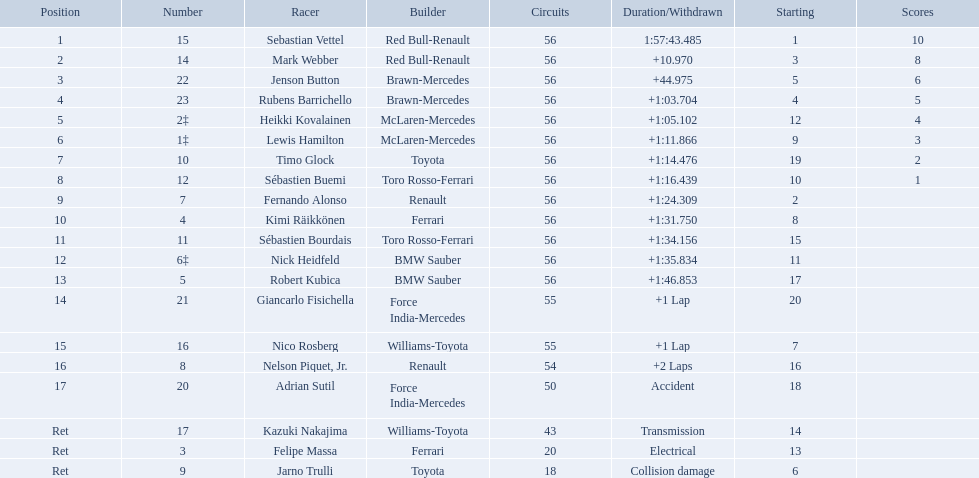Which drivers raced in the 2009 chinese grand prix? Sebastian Vettel, Mark Webber, Jenson Button, Rubens Barrichello, Heikki Kovalainen, Lewis Hamilton, Timo Glock, Sébastien Buemi, Fernando Alonso, Kimi Räikkönen, Sébastien Bourdais, Nick Heidfeld, Robert Kubica, Giancarlo Fisichella, Nico Rosberg, Nelson Piquet, Jr., Adrian Sutil, Kazuki Nakajima, Felipe Massa, Jarno Trulli. Help me parse the entirety of this table. {'header': ['Position', 'Number', 'Racer', 'Builder', 'Circuits', 'Duration/Withdrawn', 'Starting', 'Scores'], 'rows': [['1', '15', 'Sebastian Vettel', 'Red Bull-Renault', '56', '1:57:43.485', '1', '10'], ['2', '14', 'Mark Webber', 'Red Bull-Renault', '56', '+10.970', '3', '8'], ['3', '22', 'Jenson Button', 'Brawn-Mercedes', '56', '+44.975', '5', '6'], ['4', '23', 'Rubens Barrichello', 'Brawn-Mercedes', '56', '+1:03.704', '4', '5'], ['5', '2‡', 'Heikki Kovalainen', 'McLaren-Mercedes', '56', '+1:05.102', '12', '4'], ['6', '1‡', 'Lewis Hamilton', 'McLaren-Mercedes', '56', '+1:11.866', '9', '3'], ['7', '10', 'Timo Glock', 'Toyota', '56', '+1:14.476', '19', '2'], ['8', '12', 'Sébastien Buemi', 'Toro Rosso-Ferrari', '56', '+1:16.439', '10', '1'], ['9', '7', 'Fernando Alonso', 'Renault', '56', '+1:24.309', '2', ''], ['10', '4', 'Kimi Räikkönen', 'Ferrari', '56', '+1:31.750', '8', ''], ['11', '11', 'Sébastien Bourdais', 'Toro Rosso-Ferrari', '56', '+1:34.156', '15', ''], ['12', '6‡', 'Nick Heidfeld', 'BMW Sauber', '56', '+1:35.834', '11', ''], ['13', '5', 'Robert Kubica', 'BMW Sauber', '56', '+1:46.853', '17', ''], ['14', '21', 'Giancarlo Fisichella', 'Force India-Mercedes', '55', '+1 Lap', '20', ''], ['15', '16', 'Nico Rosberg', 'Williams-Toyota', '55', '+1 Lap', '7', ''], ['16', '8', 'Nelson Piquet, Jr.', 'Renault', '54', '+2 Laps', '16', ''], ['17', '20', 'Adrian Sutil', 'Force India-Mercedes', '50', 'Accident', '18', ''], ['Ret', '17', 'Kazuki Nakajima', 'Williams-Toyota', '43', 'Transmission', '14', ''], ['Ret', '3', 'Felipe Massa', 'Ferrari', '20', 'Electrical', '13', ''], ['Ret', '9', 'Jarno Trulli', 'Toyota', '18', 'Collision damage', '6', '']]} Of the drivers in the 2009 chinese grand prix, which finished the race? Sebastian Vettel, Mark Webber, Jenson Button, Rubens Barrichello, Heikki Kovalainen, Lewis Hamilton, Timo Glock, Sébastien Buemi, Fernando Alonso, Kimi Räikkönen, Sébastien Bourdais, Nick Heidfeld, Robert Kubica. Of the drivers who finished the race, who had the slowest time? Robert Kubica. Can you give me this table in json format? {'header': ['Position', 'Number', 'Racer', 'Builder', 'Circuits', 'Duration/Withdrawn', 'Starting', 'Scores'], 'rows': [['1', '15', 'Sebastian Vettel', 'Red Bull-Renault', '56', '1:57:43.485', '1', '10'], ['2', '14', 'Mark Webber', 'Red Bull-Renault', '56', '+10.970', '3', '8'], ['3', '22', 'Jenson Button', 'Brawn-Mercedes', '56', '+44.975', '5', '6'], ['4', '23', 'Rubens Barrichello', 'Brawn-Mercedes', '56', '+1:03.704', '4', '5'], ['5', '2‡', 'Heikki Kovalainen', 'McLaren-Mercedes', '56', '+1:05.102', '12', '4'], ['6', '1‡', 'Lewis Hamilton', 'McLaren-Mercedes', '56', '+1:11.866', '9', '3'], ['7', '10', 'Timo Glock', 'Toyota', '56', '+1:14.476', '19', '2'], ['8', '12', 'Sébastien Buemi', 'Toro Rosso-Ferrari', '56', '+1:16.439', '10', '1'], ['9', '7', 'Fernando Alonso', 'Renault', '56', '+1:24.309', '2', ''], ['10', '4', 'Kimi Räikkönen', 'Ferrari', '56', '+1:31.750', '8', ''], ['11', '11', 'Sébastien Bourdais', 'Toro Rosso-Ferrari', '56', '+1:34.156', '15', ''], ['12', '6‡', 'Nick Heidfeld', 'BMW Sauber', '56', '+1:35.834', '11', ''], ['13', '5', 'Robert Kubica', 'BMW Sauber', '56', '+1:46.853', '17', ''], ['14', '21', 'Giancarlo Fisichella', 'Force India-Mercedes', '55', '+1 Lap', '20', ''], ['15', '16', 'Nico Rosberg', 'Williams-Toyota', '55', '+1 Lap', '7', ''], ['16', '8', 'Nelson Piquet, Jr.', 'Renault', '54', '+2 Laps', '16', ''], ['17', '20', 'Adrian Sutil', 'Force India-Mercedes', '50', 'Accident', '18', ''], ['Ret', '17', 'Kazuki Nakajima', 'Williams-Toyota', '43', 'Transmission', '14', ''], ['Ret', '3', 'Felipe Massa', 'Ferrari', '20', 'Electrical', '13', ''], ['Ret', '9', 'Jarno Trulli', 'Toyota', '18', 'Collision damage', '6', '']]} Who are all the drivers? Sebastian Vettel, Mark Webber, Jenson Button, Rubens Barrichello, Heikki Kovalainen, Lewis Hamilton, Timo Glock, Sébastien Buemi, Fernando Alonso, Kimi Räikkönen, Sébastien Bourdais, Nick Heidfeld, Robert Kubica, Giancarlo Fisichella, Nico Rosberg, Nelson Piquet, Jr., Adrian Sutil, Kazuki Nakajima, Felipe Massa, Jarno Trulli. What were their finishing times? 1:57:43.485, +10.970, +44.975, +1:03.704, +1:05.102, +1:11.866, +1:14.476, +1:16.439, +1:24.309, +1:31.750, +1:34.156, +1:35.834, +1:46.853, +1 Lap, +1 Lap, +2 Laps, Accident, Transmission, Electrical, Collision damage. Who finished last? Robert Kubica. Who were the drivers at the 2009 chinese grand prix? Sebastian Vettel, Mark Webber, Jenson Button, Rubens Barrichello, Heikki Kovalainen, Lewis Hamilton, Timo Glock, Sébastien Buemi, Fernando Alonso, Kimi Räikkönen, Sébastien Bourdais, Nick Heidfeld, Robert Kubica, Giancarlo Fisichella, Nico Rosberg, Nelson Piquet, Jr., Adrian Sutil, Kazuki Nakajima, Felipe Massa, Jarno Trulli. Who had the slowest time? Robert Kubica. Who were all of the drivers in the 2009 chinese grand prix? Sebastian Vettel, Mark Webber, Jenson Button, Rubens Barrichello, Heikki Kovalainen, Lewis Hamilton, Timo Glock, Sébastien Buemi, Fernando Alonso, Kimi Räikkönen, Sébastien Bourdais, Nick Heidfeld, Robert Kubica, Giancarlo Fisichella, Nico Rosberg, Nelson Piquet, Jr., Adrian Sutil, Kazuki Nakajima, Felipe Massa, Jarno Trulli. And what were their finishing times? 1:57:43.485, +10.970, +44.975, +1:03.704, +1:05.102, +1:11.866, +1:14.476, +1:16.439, +1:24.309, +1:31.750, +1:34.156, +1:35.834, +1:46.853, +1 Lap, +1 Lap, +2 Laps, Accident, Transmission, Electrical, Collision damage. Which player faced collision damage and retired from the race? Jarno Trulli. 